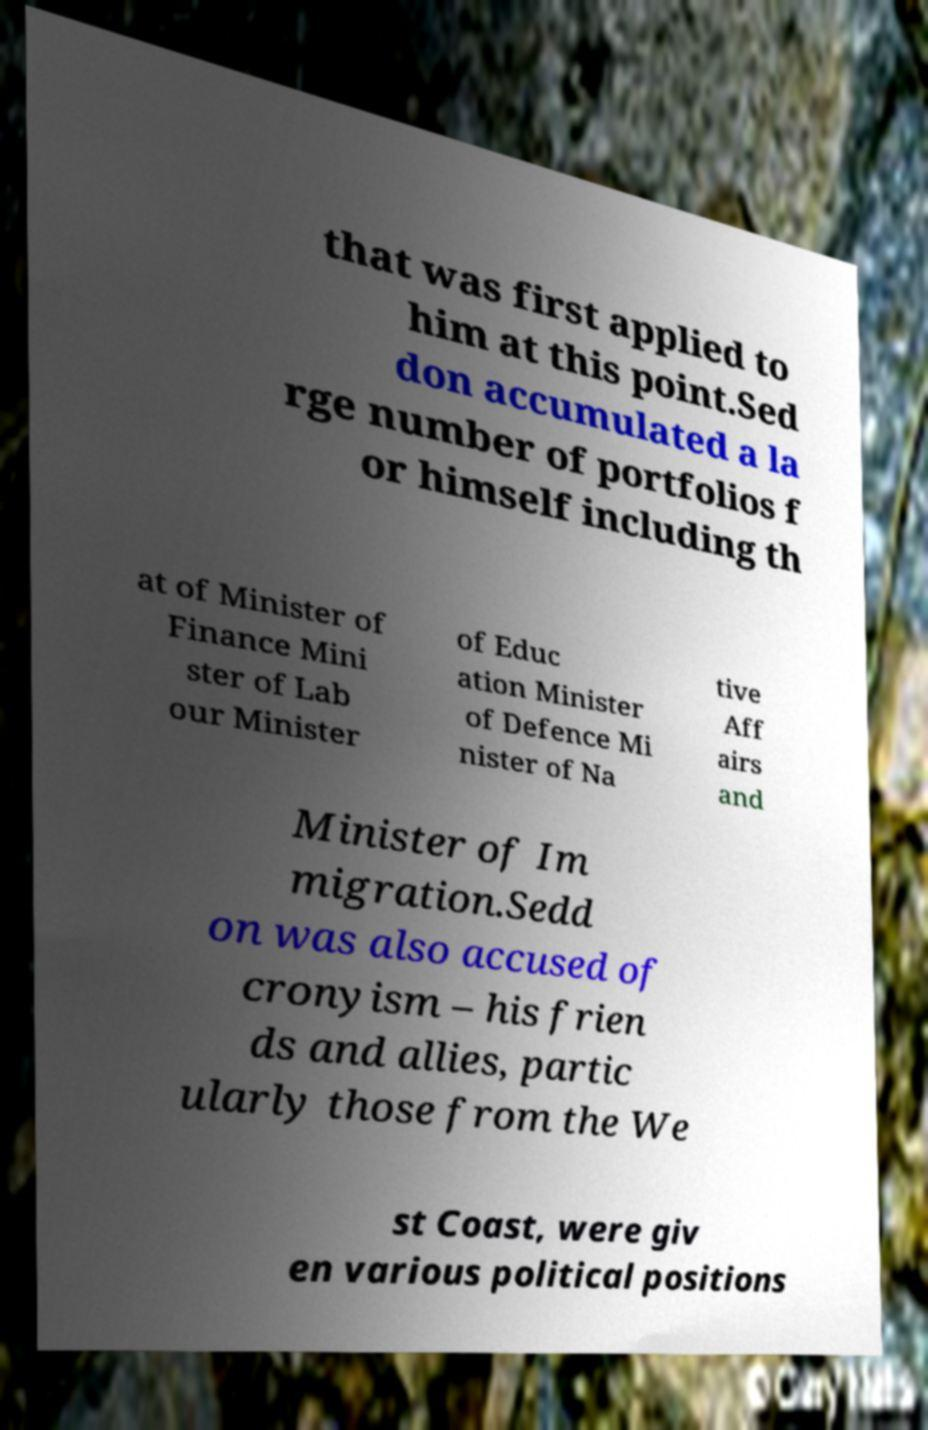I need the written content from this picture converted into text. Can you do that? that was first applied to him at this point.Sed don accumulated a la rge number of portfolios f or himself including th at of Minister of Finance Mini ster of Lab our Minister of Educ ation Minister of Defence Mi nister of Na tive Aff airs and Minister of Im migration.Sedd on was also accused of cronyism – his frien ds and allies, partic ularly those from the We st Coast, were giv en various political positions 